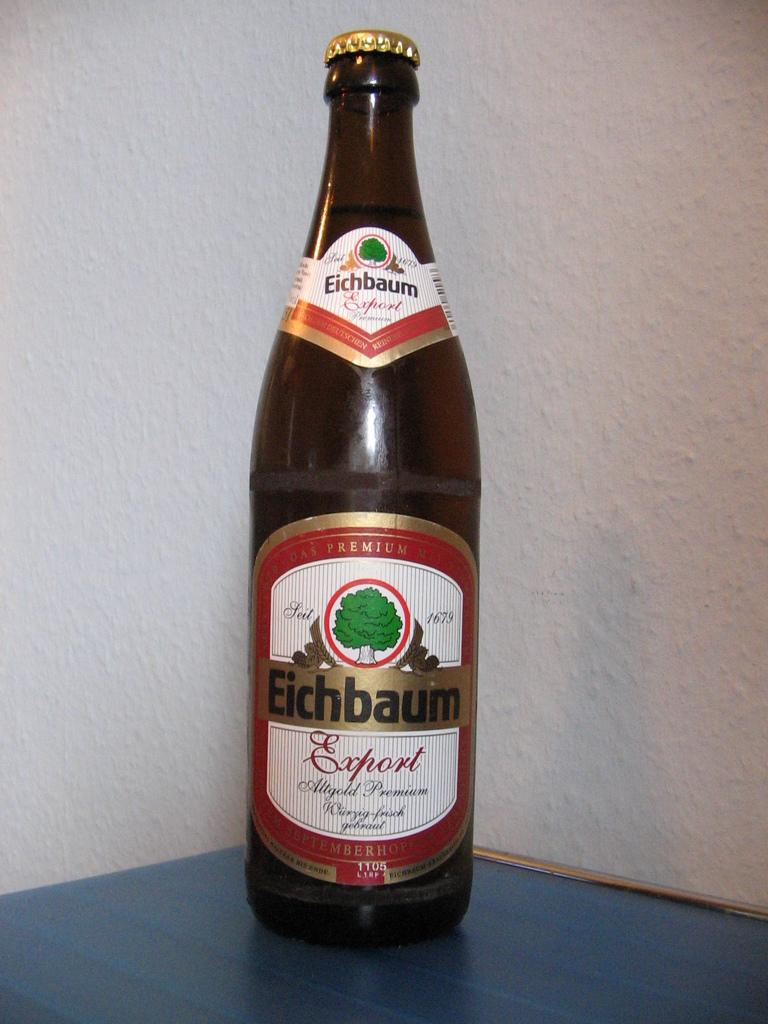<image>
Share a concise interpretation of the image provided. A bottle of Eichbaum Export against a white walll 